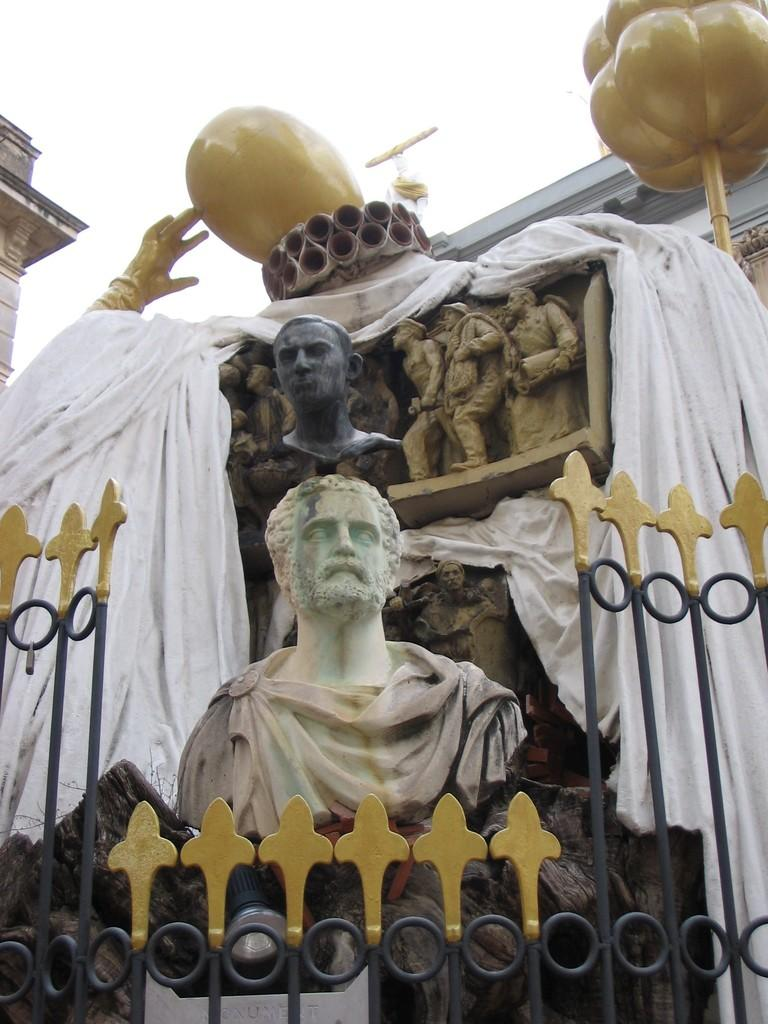What type of structure can be seen in the image? There are iron grills in the image. What artistic elements are present in the image? There are sculptures of people in the image. What material is present in the image? There is a cloth in the image. What type of man-made structures can be seen in the image? There are buildings in the image. What can be seen in the background of the image? The sky is visible in the background of the image. What time of day is it in the image, and who is the secretary of the governor? The time of day cannot be determined from the image, and there is no information about a secretary or governor in the image. 